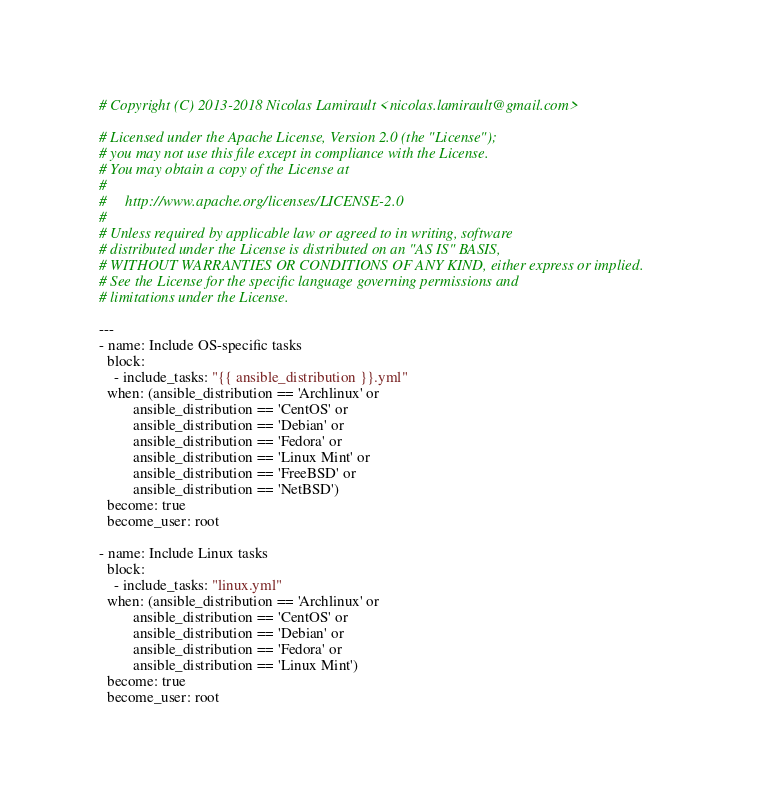<code> <loc_0><loc_0><loc_500><loc_500><_YAML_># Copyright (C) 2013-2018 Nicolas Lamirault <nicolas.lamirault@gmail.com>

# Licensed under the Apache License, Version 2.0 (the "License");
# you may not use this file except in compliance with the License.
# You may obtain a copy of the License at
#
#     http://www.apache.org/licenses/LICENSE-2.0
#
# Unless required by applicable law or agreed to in writing, software
# distributed under the License is distributed on an "AS IS" BASIS,
# WITHOUT WARRANTIES OR CONDITIONS OF ANY KIND, either express or implied.
# See the License for the specific language governing permissions and
# limitations under the License.

---
- name: Include OS-specific tasks
  block:
    - include_tasks: "{{ ansible_distribution }}.yml"
  when: (ansible_distribution == 'Archlinux' or
         ansible_distribution == 'CentOS' or
         ansible_distribution == 'Debian' or
         ansible_distribution == 'Fedora' or
         ansible_distribution == 'Linux Mint' or
         ansible_distribution == 'FreeBSD' or
         ansible_distribution == 'NetBSD')
  become: true
  become_user: root

- name: Include Linux tasks
  block:
    - include_tasks: "linux.yml"
  when: (ansible_distribution == 'Archlinux' or
         ansible_distribution == 'CentOS' or
         ansible_distribution == 'Debian' or
         ansible_distribution == 'Fedora' or
         ansible_distribution == 'Linux Mint')
  become: true
  become_user: root
</code> 